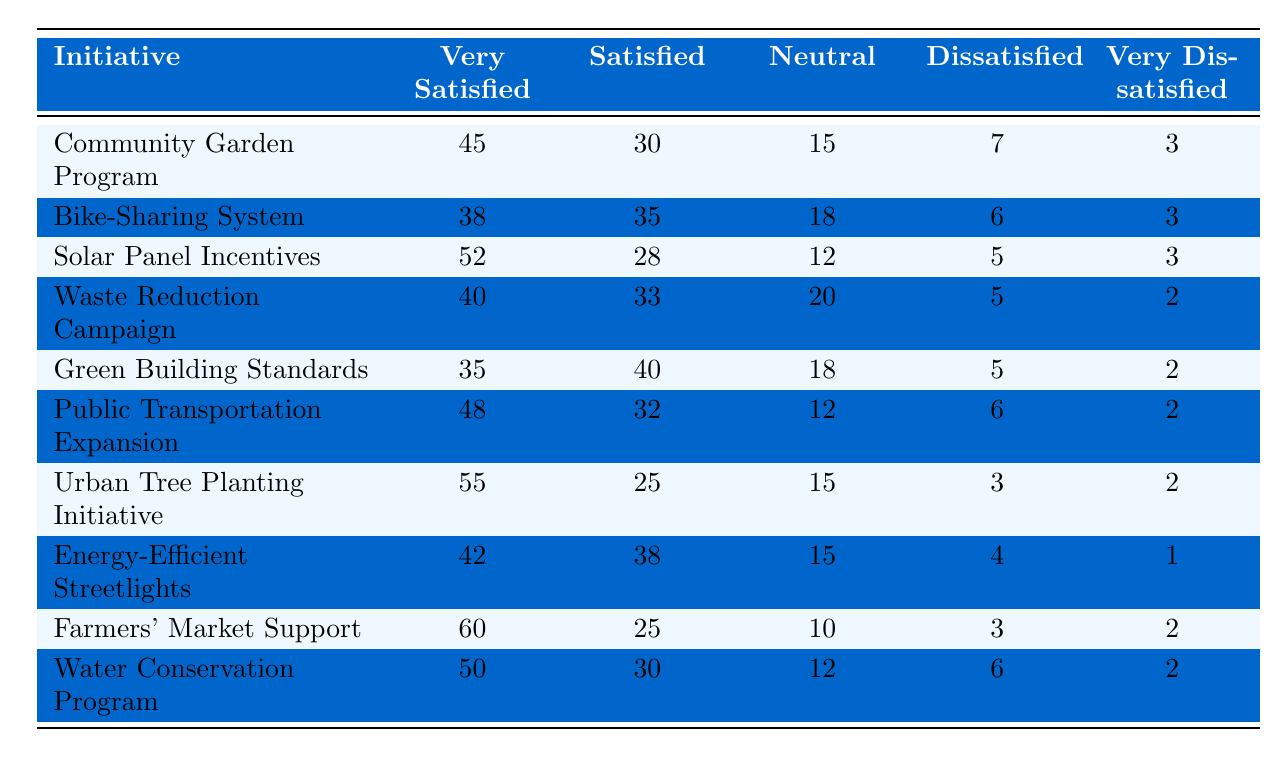What percentage of residents are very satisfied with the Farmers' Market Support initiative? According to the table, the value under the "Very Satisfied" column for the Farmers' Market Support initiative is 60. Since this is already in percentage form, the answer is directly taken from the table.
Answer: 60% Which initiative has the highest percentage of residents reporting dissatisfaction? By comparing the "Dissatisfied" and "Very Dissatisfied" columns for each initiative, the Waste Reduction Campaign has 5 dissatisfied and 2 very dissatisfied, totaling 7. All other initiatives have lower totals.
Answer: Waste Reduction Campaign What is the average percentage of residents who are satisfied (both satisfied and very satisfied) with the Bike-Sharing System and Urban Tree Planting Initiative? For Bike-Sharing, the totals for "Satisfied" (35) and "Very Satisfied" (38) add up to 73. For Urban Tree Planting, "Satisfied" (25) plus "Very Satisfied" (55) total 80. Thus, the average is (73 + 80) / 2 = 76.5.
Answer: 76.5 Is the percentage of residents who are very satisfied with Solar Panel Incentives greater than those who are very satisfied with Green Building Standards? Solar Panel Incentives has 52 residents very satisfied while Green Building Standards has 35. Since 52 is greater than 35, the answer is yes.
Answer: Yes Calculate the difference in the percentage of residents who are very satisfied with the Community Garden Program and the Water Conservation Program. Community Garden Program has 45 reporting very satisfied, while Water Conservation Program has 50. The difference is calculated as 50 - 45 = 5.
Answer: 5 